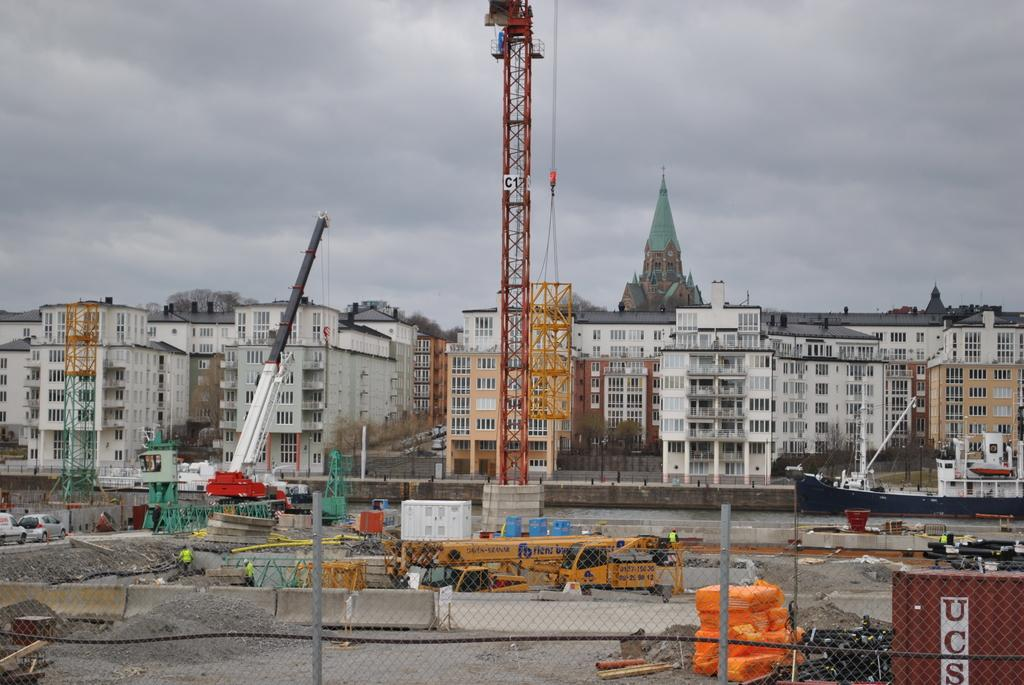What type of structure can be seen in the image? There is a fencing in the image. What is the primary activity taking place in the image? There is a construction site in the image. What types of vehicles are present in the image? There are vehicles in the image. What type of man-made structures can be seen in the image? There are buildings in the image. Can you see a whip being used to control a beast in the image? No, there is no whip or beast present in the image. How many push-ups are being performed in the image? There is no person performing push-ups in the image. 